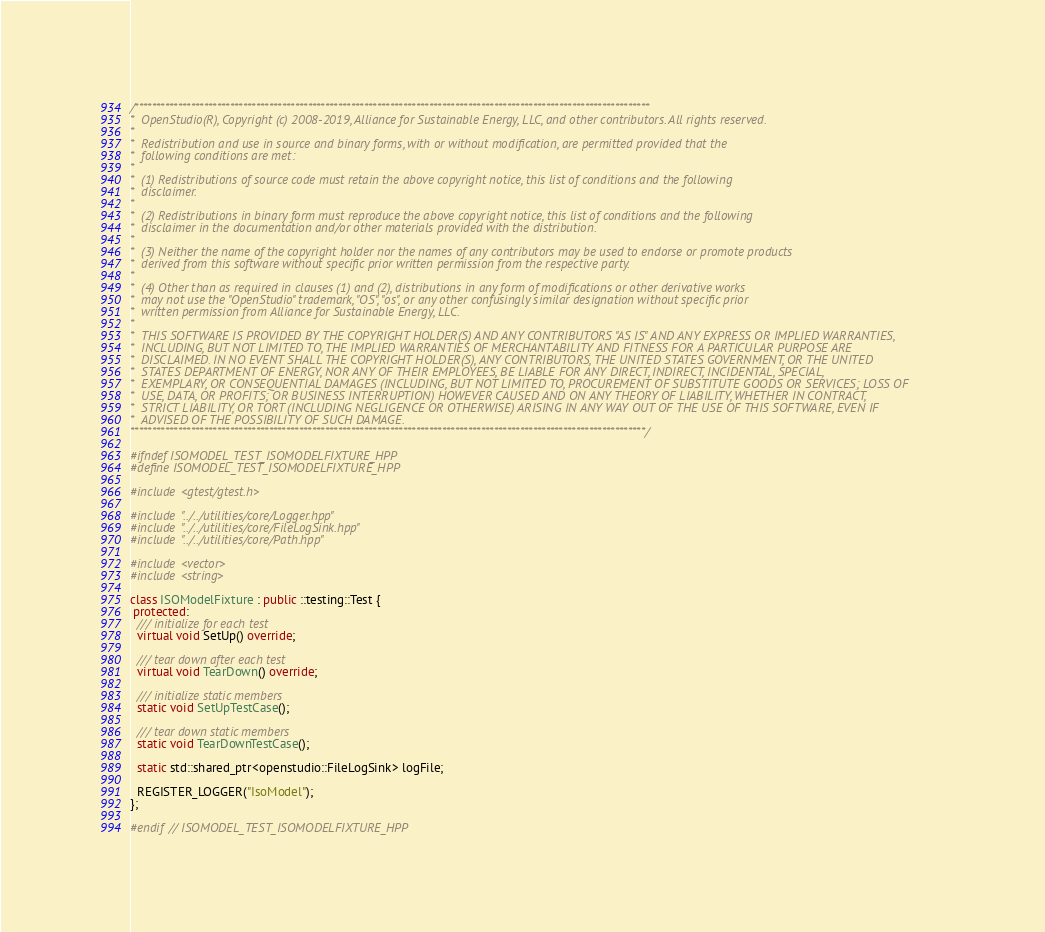Convert code to text. <code><loc_0><loc_0><loc_500><loc_500><_C++_>/***********************************************************************************************************************
*  OpenStudio(R), Copyright (c) 2008-2019, Alliance for Sustainable Energy, LLC, and other contributors. All rights reserved.
*
*  Redistribution and use in source and binary forms, with or without modification, are permitted provided that the
*  following conditions are met:
*
*  (1) Redistributions of source code must retain the above copyright notice, this list of conditions and the following
*  disclaimer.
*
*  (2) Redistributions in binary form must reproduce the above copyright notice, this list of conditions and the following
*  disclaimer in the documentation and/or other materials provided with the distribution.
*
*  (3) Neither the name of the copyright holder nor the names of any contributors may be used to endorse or promote products
*  derived from this software without specific prior written permission from the respective party.
*
*  (4) Other than as required in clauses (1) and (2), distributions in any form of modifications or other derivative works
*  may not use the "OpenStudio" trademark, "OS", "os", or any other confusingly similar designation without specific prior
*  written permission from Alliance for Sustainable Energy, LLC.
*
*  THIS SOFTWARE IS PROVIDED BY THE COPYRIGHT HOLDER(S) AND ANY CONTRIBUTORS "AS IS" AND ANY EXPRESS OR IMPLIED WARRANTIES,
*  INCLUDING, BUT NOT LIMITED TO, THE IMPLIED WARRANTIES OF MERCHANTABILITY AND FITNESS FOR A PARTICULAR PURPOSE ARE
*  DISCLAIMED. IN NO EVENT SHALL THE COPYRIGHT HOLDER(S), ANY CONTRIBUTORS, THE UNITED STATES GOVERNMENT, OR THE UNITED
*  STATES DEPARTMENT OF ENERGY, NOR ANY OF THEIR EMPLOYEES, BE LIABLE FOR ANY DIRECT, INDIRECT, INCIDENTAL, SPECIAL,
*  EXEMPLARY, OR CONSEQUENTIAL DAMAGES (INCLUDING, BUT NOT LIMITED TO, PROCUREMENT OF SUBSTITUTE GOODS OR SERVICES; LOSS OF
*  USE, DATA, OR PROFITS; OR BUSINESS INTERRUPTION) HOWEVER CAUSED AND ON ANY THEORY OF LIABILITY, WHETHER IN CONTRACT,
*  STRICT LIABILITY, OR TORT (INCLUDING NEGLIGENCE OR OTHERWISE) ARISING IN ANY WAY OUT OF THE USE OF THIS SOFTWARE, EVEN IF
*  ADVISED OF THE POSSIBILITY OF SUCH DAMAGE.
***********************************************************************************************************************/

#ifndef ISOMODEL_TEST_ISOMODELFIXTURE_HPP
#define ISOMODEL_TEST_ISOMODELFIXTURE_HPP

#include <gtest/gtest.h>

#include "../../utilities/core/Logger.hpp"
#include "../../utilities/core/FileLogSink.hpp"
#include "../../utilities/core/Path.hpp"

#include <vector>
#include <string>

class ISOModelFixture : public ::testing::Test {
 protected:
  /// initialize for each test
  virtual void SetUp() override;

  /// tear down after each test
  virtual void TearDown() override;

  /// initialize static members
  static void SetUpTestCase();

  /// tear down static members
  static void TearDownTestCase();

  static std::shared_ptr<openstudio::FileLogSink> logFile;

  REGISTER_LOGGER("IsoModel");
};

#endif // ISOMODEL_TEST_ISOMODELFIXTURE_HPP

</code> 